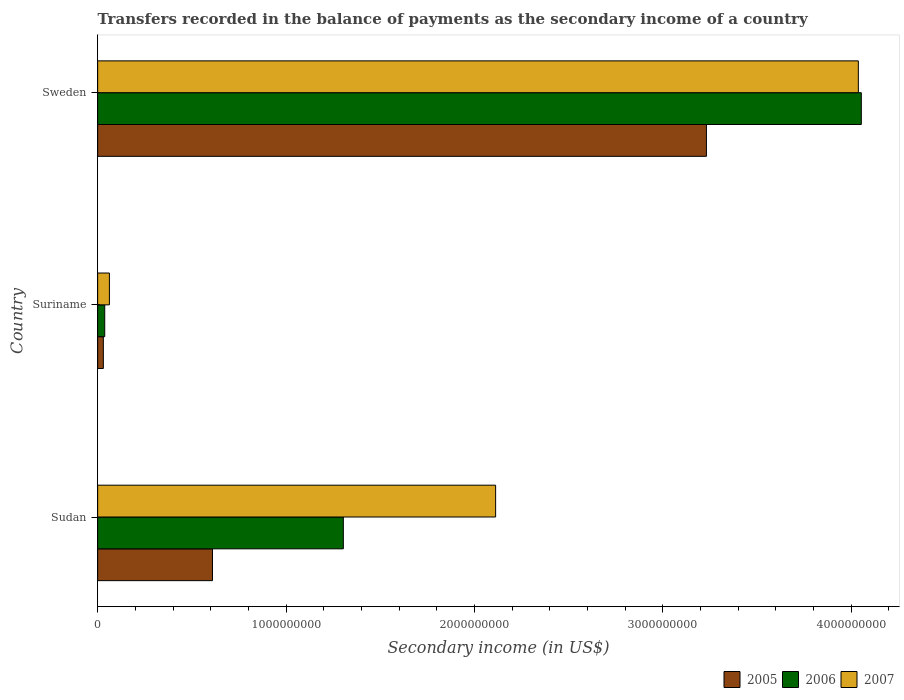How many different coloured bars are there?
Provide a succinct answer. 3. Are the number of bars per tick equal to the number of legend labels?
Give a very brief answer. Yes. How many bars are there on the 3rd tick from the bottom?
Offer a terse response. 3. What is the label of the 3rd group of bars from the top?
Ensure brevity in your answer.  Sudan. In how many cases, is the number of bars for a given country not equal to the number of legend labels?
Provide a succinct answer. 0. What is the secondary income of in 2005 in Suriname?
Offer a terse response. 3.02e+07. Across all countries, what is the maximum secondary income of in 2005?
Your response must be concise. 3.23e+09. Across all countries, what is the minimum secondary income of in 2005?
Offer a very short reply. 3.02e+07. In which country was the secondary income of in 2006 minimum?
Provide a succinct answer. Suriname. What is the total secondary income of in 2005 in the graph?
Ensure brevity in your answer.  3.87e+09. What is the difference between the secondary income of in 2007 in Sudan and that in Sweden?
Make the answer very short. -1.93e+09. What is the difference between the secondary income of in 2007 in Sudan and the secondary income of in 2006 in Sweden?
Offer a very short reply. -1.94e+09. What is the average secondary income of in 2007 per country?
Give a very brief answer. 2.07e+09. What is the difference between the secondary income of in 2007 and secondary income of in 2005 in Suriname?
Offer a very short reply. 3.22e+07. What is the ratio of the secondary income of in 2007 in Sudan to that in Suriname?
Provide a succinct answer. 33.86. Is the secondary income of in 2005 in Sudan less than that in Sweden?
Offer a terse response. Yes. What is the difference between the highest and the second highest secondary income of in 2006?
Provide a succinct answer. 2.75e+09. What is the difference between the highest and the lowest secondary income of in 2007?
Give a very brief answer. 3.98e+09. Is the sum of the secondary income of in 2006 in Suriname and Sweden greater than the maximum secondary income of in 2007 across all countries?
Give a very brief answer. Yes. What does the 1st bar from the top in Sudan represents?
Your answer should be very brief. 2007. What does the 2nd bar from the bottom in Suriname represents?
Make the answer very short. 2006. Are all the bars in the graph horizontal?
Ensure brevity in your answer.  Yes. Does the graph contain any zero values?
Your response must be concise. No. Where does the legend appear in the graph?
Your answer should be compact. Bottom right. How are the legend labels stacked?
Ensure brevity in your answer.  Horizontal. What is the title of the graph?
Your answer should be very brief. Transfers recorded in the balance of payments as the secondary income of a country. Does "1978" appear as one of the legend labels in the graph?
Ensure brevity in your answer.  No. What is the label or title of the X-axis?
Your answer should be very brief. Secondary income (in US$). What is the label or title of the Y-axis?
Your answer should be compact. Country. What is the Secondary income (in US$) of 2005 in Sudan?
Your response must be concise. 6.10e+08. What is the Secondary income (in US$) of 2006 in Sudan?
Offer a terse response. 1.30e+09. What is the Secondary income (in US$) of 2007 in Sudan?
Your answer should be very brief. 2.11e+09. What is the Secondary income (in US$) of 2005 in Suriname?
Offer a terse response. 3.02e+07. What is the Secondary income (in US$) in 2006 in Suriname?
Give a very brief answer. 3.76e+07. What is the Secondary income (in US$) in 2007 in Suriname?
Offer a terse response. 6.24e+07. What is the Secondary income (in US$) of 2005 in Sweden?
Your answer should be very brief. 3.23e+09. What is the Secondary income (in US$) of 2006 in Sweden?
Offer a terse response. 4.05e+09. What is the Secondary income (in US$) in 2007 in Sweden?
Make the answer very short. 4.04e+09. Across all countries, what is the maximum Secondary income (in US$) in 2005?
Provide a short and direct response. 3.23e+09. Across all countries, what is the maximum Secondary income (in US$) in 2006?
Make the answer very short. 4.05e+09. Across all countries, what is the maximum Secondary income (in US$) of 2007?
Keep it short and to the point. 4.04e+09. Across all countries, what is the minimum Secondary income (in US$) in 2005?
Offer a very short reply. 3.02e+07. Across all countries, what is the minimum Secondary income (in US$) of 2006?
Your answer should be very brief. 3.76e+07. Across all countries, what is the minimum Secondary income (in US$) in 2007?
Ensure brevity in your answer.  6.24e+07. What is the total Secondary income (in US$) of 2005 in the graph?
Give a very brief answer. 3.87e+09. What is the total Secondary income (in US$) of 2006 in the graph?
Your answer should be compact. 5.40e+09. What is the total Secondary income (in US$) in 2007 in the graph?
Ensure brevity in your answer.  6.21e+09. What is the difference between the Secondary income (in US$) in 2005 in Sudan and that in Suriname?
Your answer should be compact. 5.79e+08. What is the difference between the Secondary income (in US$) of 2006 in Sudan and that in Suriname?
Keep it short and to the point. 1.27e+09. What is the difference between the Secondary income (in US$) in 2007 in Sudan and that in Suriname?
Your answer should be compact. 2.05e+09. What is the difference between the Secondary income (in US$) in 2005 in Sudan and that in Sweden?
Keep it short and to the point. -2.62e+09. What is the difference between the Secondary income (in US$) of 2006 in Sudan and that in Sweden?
Your answer should be compact. -2.75e+09. What is the difference between the Secondary income (in US$) in 2007 in Sudan and that in Sweden?
Your response must be concise. -1.93e+09. What is the difference between the Secondary income (in US$) in 2005 in Suriname and that in Sweden?
Your answer should be very brief. -3.20e+09. What is the difference between the Secondary income (in US$) of 2006 in Suriname and that in Sweden?
Make the answer very short. -4.02e+09. What is the difference between the Secondary income (in US$) in 2007 in Suriname and that in Sweden?
Give a very brief answer. -3.98e+09. What is the difference between the Secondary income (in US$) in 2005 in Sudan and the Secondary income (in US$) in 2006 in Suriname?
Your answer should be very brief. 5.72e+08. What is the difference between the Secondary income (in US$) of 2005 in Sudan and the Secondary income (in US$) of 2007 in Suriname?
Your response must be concise. 5.47e+08. What is the difference between the Secondary income (in US$) in 2006 in Sudan and the Secondary income (in US$) in 2007 in Suriname?
Offer a very short reply. 1.24e+09. What is the difference between the Secondary income (in US$) of 2005 in Sudan and the Secondary income (in US$) of 2006 in Sweden?
Your answer should be very brief. -3.44e+09. What is the difference between the Secondary income (in US$) in 2005 in Sudan and the Secondary income (in US$) in 2007 in Sweden?
Give a very brief answer. -3.43e+09. What is the difference between the Secondary income (in US$) in 2006 in Sudan and the Secondary income (in US$) in 2007 in Sweden?
Offer a terse response. -2.73e+09. What is the difference between the Secondary income (in US$) in 2005 in Suriname and the Secondary income (in US$) in 2006 in Sweden?
Ensure brevity in your answer.  -4.02e+09. What is the difference between the Secondary income (in US$) of 2005 in Suriname and the Secondary income (in US$) of 2007 in Sweden?
Keep it short and to the point. -4.01e+09. What is the difference between the Secondary income (in US$) of 2006 in Suriname and the Secondary income (in US$) of 2007 in Sweden?
Your answer should be compact. -4.00e+09. What is the average Secondary income (in US$) in 2005 per country?
Offer a very short reply. 1.29e+09. What is the average Secondary income (in US$) of 2006 per country?
Offer a very short reply. 1.80e+09. What is the average Secondary income (in US$) of 2007 per country?
Your answer should be compact. 2.07e+09. What is the difference between the Secondary income (in US$) of 2005 and Secondary income (in US$) of 2006 in Sudan?
Your response must be concise. -6.95e+08. What is the difference between the Secondary income (in US$) in 2005 and Secondary income (in US$) in 2007 in Sudan?
Provide a short and direct response. -1.50e+09. What is the difference between the Secondary income (in US$) in 2006 and Secondary income (in US$) in 2007 in Sudan?
Offer a very short reply. -8.08e+08. What is the difference between the Secondary income (in US$) in 2005 and Secondary income (in US$) in 2006 in Suriname?
Provide a short and direct response. -7.40e+06. What is the difference between the Secondary income (in US$) of 2005 and Secondary income (in US$) of 2007 in Suriname?
Make the answer very short. -3.22e+07. What is the difference between the Secondary income (in US$) in 2006 and Secondary income (in US$) in 2007 in Suriname?
Offer a very short reply. -2.48e+07. What is the difference between the Secondary income (in US$) of 2005 and Secondary income (in US$) of 2006 in Sweden?
Offer a very short reply. -8.22e+08. What is the difference between the Secondary income (in US$) of 2005 and Secondary income (in US$) of 2007 in Sweden?
Your response must be concise. -8.06e+08. What is the difference between the Secondary income (in US$) of 2006 and Secondary income (in US$) of 2007 in Sweden?
Make the answer very short. 1.58e+07. What is the ratio of the Secondary income (in US$) in 2005 in Sudan to that in Suriname?
Provide a succinct answer. 20.19. What is the ratio of the Secondary income (in US$) of 2006 in Sudan to that in Suriname?
Make the answer very short. 34.69. What is the ratio of the Secondary income (in US$) of 2007 in Sudan to that in Suriname?
Provide a short and direct response. 33.86. What is the ratio of the Secondary income (in US$) of 2005 in Sudan to that in Sweden?
Your answer should be compact. 0.19. What is the ratio of the Secondary income (in US$) in 2006 in Sudan to that in Sweden?
Offer a terse response. 0.32. What is the ratio of the Secondary income (in US$) of 2007 in Sudan to that in Sweden?
Your response must be concise. 0.52. What is the ratio of the Secondary income (in US$) in 2005 in Suriname to that in Sweden?
Offer a very short reply. 0.01. What is the ratio of the Secondary income (in US$) in 2006 in Suriname to that in Sweden?
Your response must be concise. 0.01. What is the ratio of the Secondary income (in US$) in 2007 in Suriname to that in Sweden?
Ensure brevity in your answer.  0.02. What is the difference between the highest and the second highest Secondary income (in US$) of 2005?
Ensure brevity in your answer.  2.62e+09. What is the difference between the highest and the second highest Secondary income (in US$) in 2006?
Ensure brevity in your answer.  2.75e+09. What is the difference between the highest and the second highest Secondary income (in US$) in 2007?
Your response must be concise. 1.93e+09. What is the difference between the highest and the lowest Secondary income (in US$) in 2005?
Offer a terse response. 3.20e+09. What is the difference between the highest and the lowest Secondary income (in US$) of 2006?
Provide a short and direct response. 4.02e+09. What is the difference between the highest and the lowest Secondary income (in US$) of 2007?
Ensure brevity in your answer.  3.98e+09. 